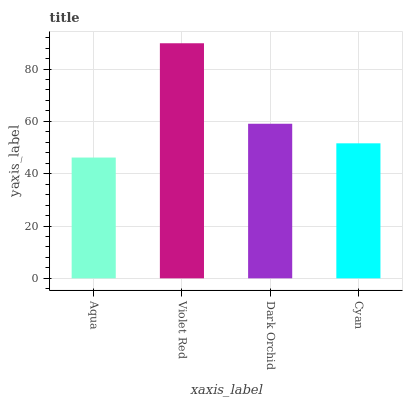Is Aqua the minimum?
Answer yes or no. Yes. Is Violet Red the maximum?
Answer yes or no. Yes. Is Dark Orchid the minimum?
Answer yes or no. No. Is Dark Orchid the maximum?
Answer yes or no. No. Is Violet Red greater than Dark Orchid?
Answer yes or no. Yes. Is Dark Orchid less than Violet Red?
Answer yes or no. Yes. Is Dark Orchid greater than Violet Red?
Answer yes or no. No. Is Violet Red less than Dark Orchid?
Answer yes or no. No. Is Dark Orchid the high median?
Answer yes or no. Yes. Is Cyan the low median?
Answer yes or no. Yes. Is Violet Red the high median?
Answer yes or no. No. Is Dark Orchid the low median?
Answer yes or no. No. 